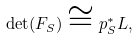<formula> <loc_0><loc_0><loc_500><loc_500>\det ( F _ { S } ) \cong p _ { S } ^ { * } L ,</formula> 